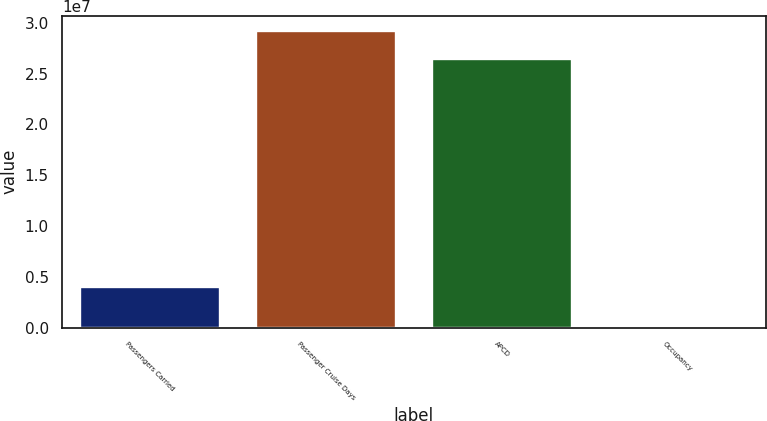Convert chart to OTSL. <chart><loc_0><loc_0><loc_500><loc_500><bar_chart><fcel>Passengers Carried<fcel>Passenger Cruise Days<fcel>APCD<fcel>Occupancy<nl><fcel>4.01755e+06<fcel>2.92294e+07<fcel>2.64636e+07<fcel>104.5<nl></chart> 